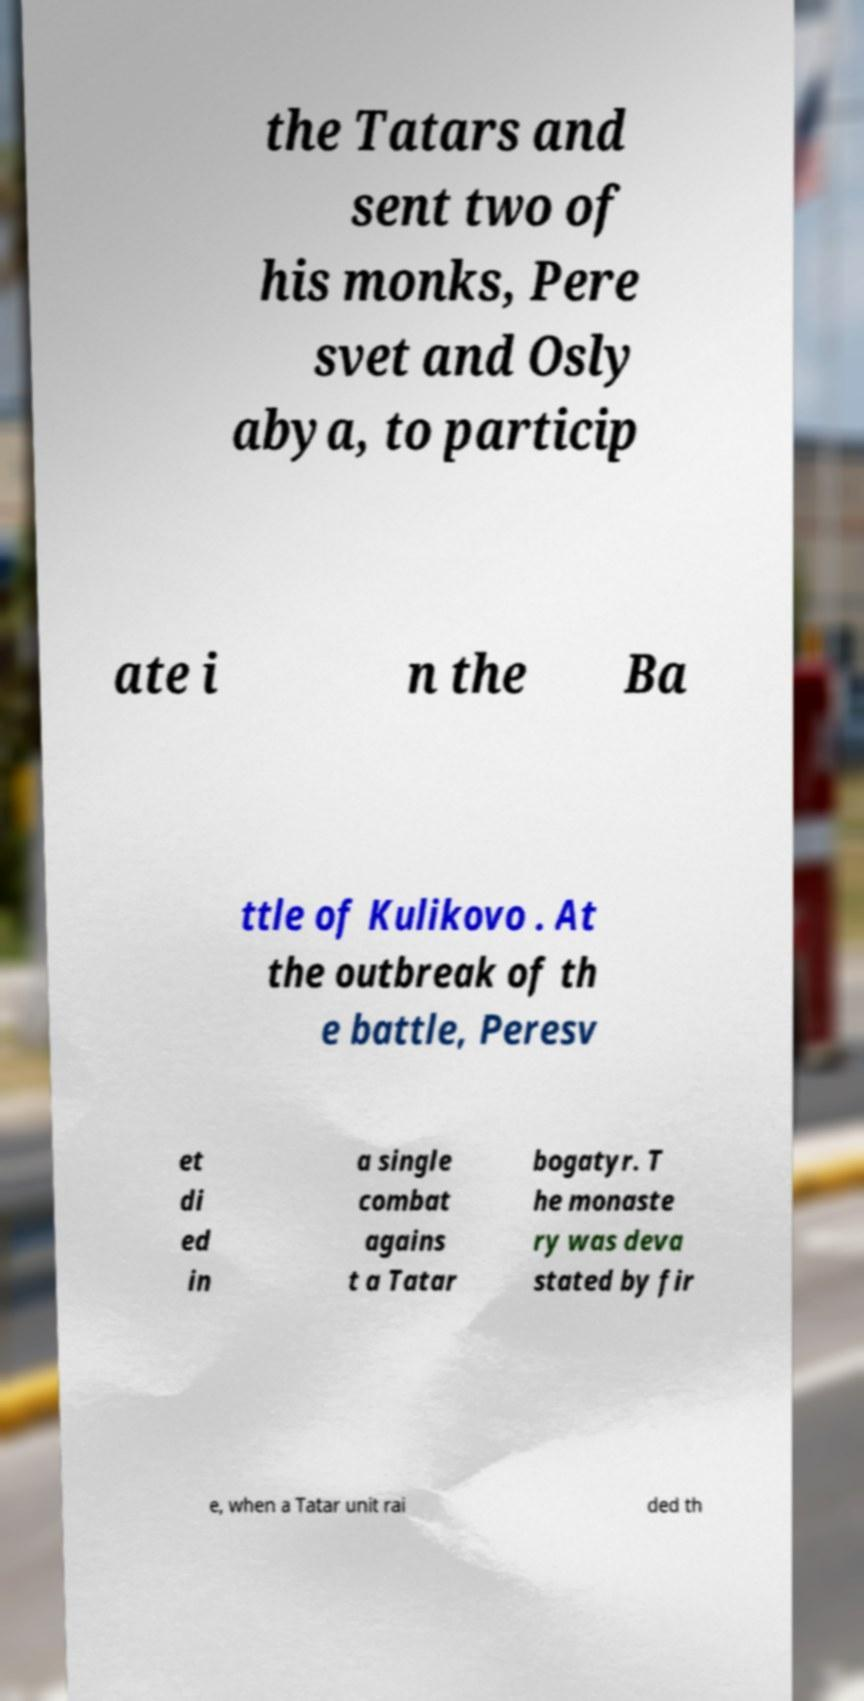What messages or text are displayed in this image? I need them in a readable, typed format. the Tatars and sent two of his monks, Pere svet and Osly abya, to particip ate i n the Ba ttle of Kulikovo . At the outbreak of th e battle, Peresv et di ed in a single combat agains t a Tatar bogatyr. T he monaste ry was deva stated by fir e, when a Tatar unit rai ded th 